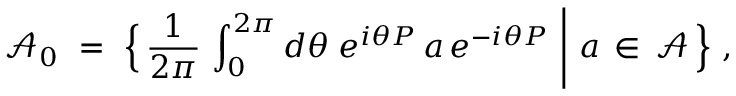Convert formula to latex. <formula><loc_0><loc_0><loc_500><loc_500>{ \mathcal { A } } _ { 0 } \ = \ \Big \{ \, \frac { 1 } { 2 \pi } \, \int _ { 0 } ^ { 2 \pi } d \theta \, e ^ { i \theta P } \, a \, e ^ { - i \theta P } \ \Big | \ a \, \in \, { \mathcal { A } } \, \Big \} \ ,</formula> 